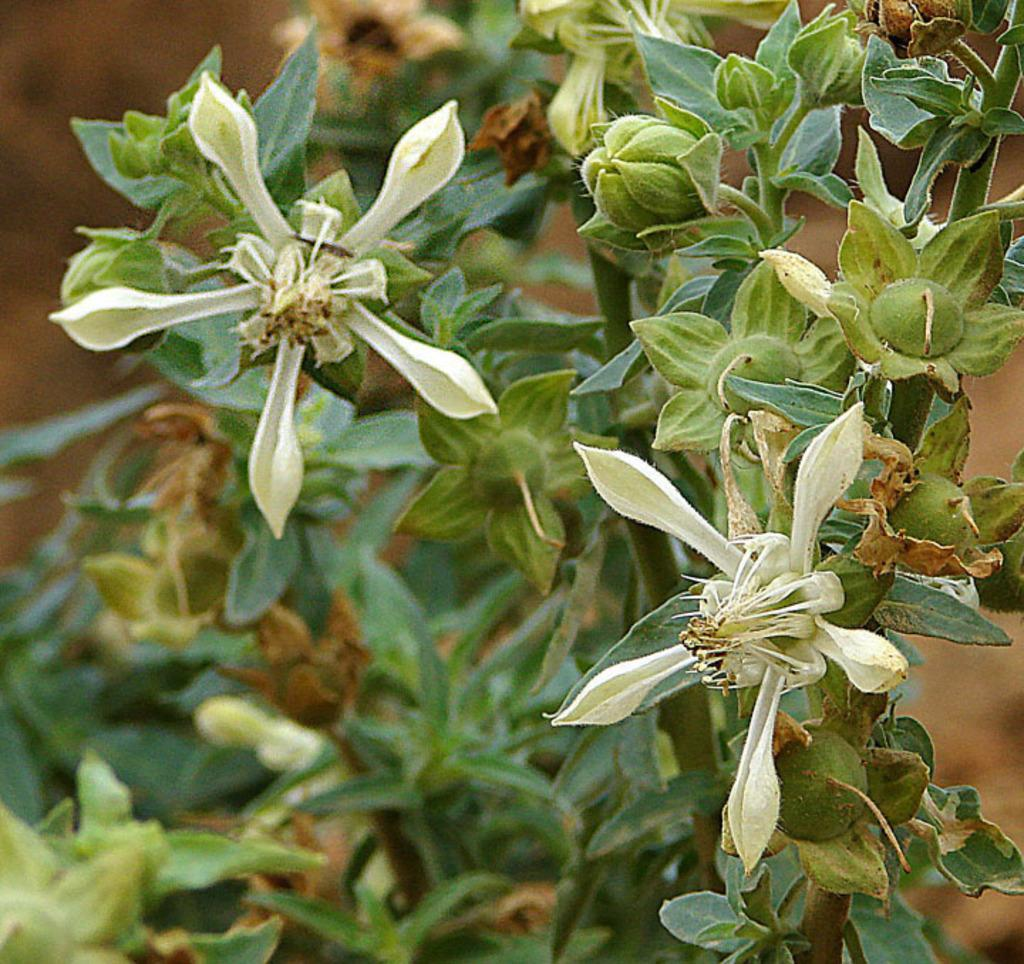What type of plant is visible in the image? There is a plant in the image. What additional features can be seen on the plant? There are flowers and buds visible on the plant. Can you describe the background of the image? The background of the image is blurred. Where is the cannon located in the image? There is no cannon present in the image. What is your mom doing in the image? There is no reference to a mom or any person in the image. Is the bed visible in the image? There is no bed present in the image. 